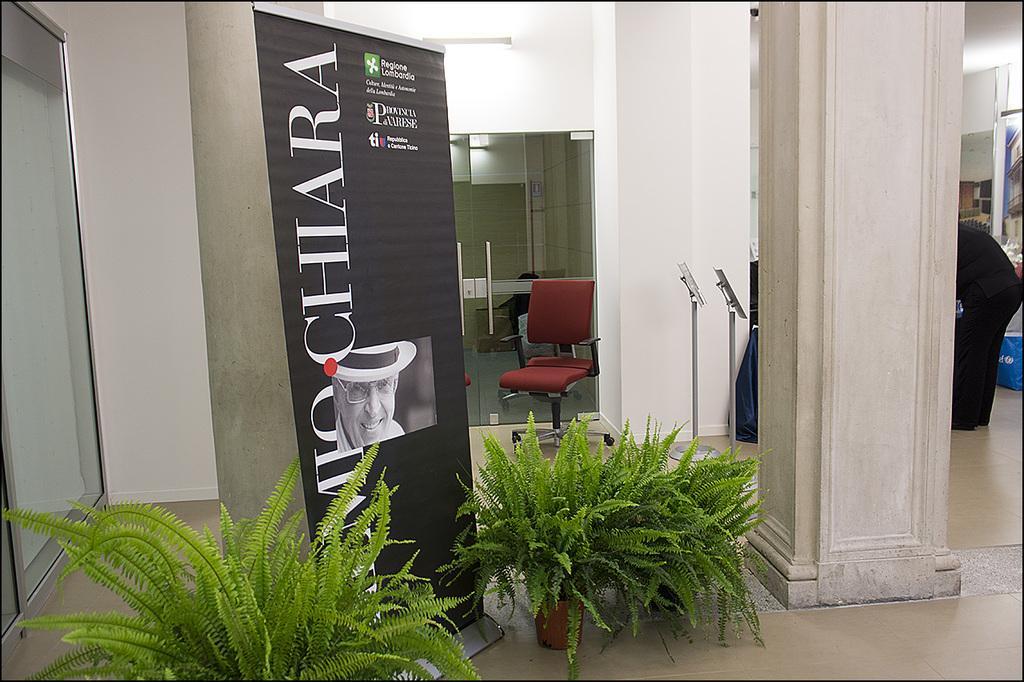Could you give a brief overview of what you see in this image? In this picture we can see house plants on the ground. There is a banner. In this banner, we can see some text and a person. We can see a few glass objects on the left side. There are pillars, stands, chair and a person is visible on the right side. We can see a few things visible in the background. 